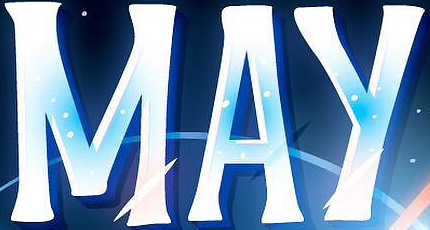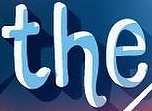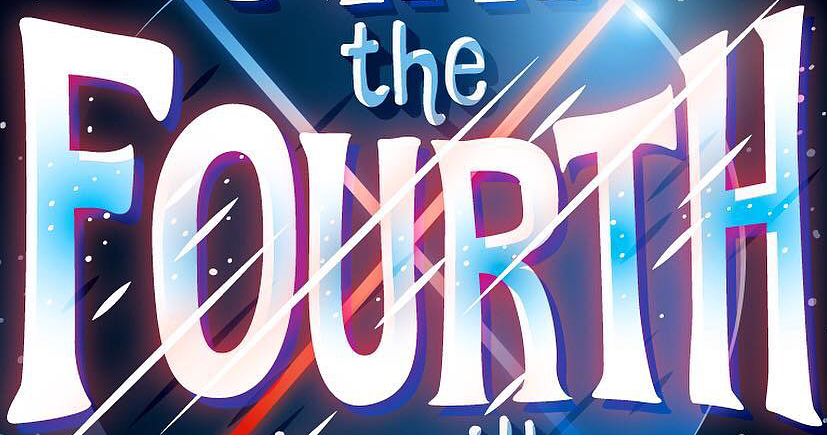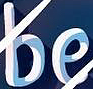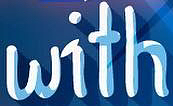Read the text from these images in sequence, separated by a semicolon. MAY; the; FOURTH; be; with 